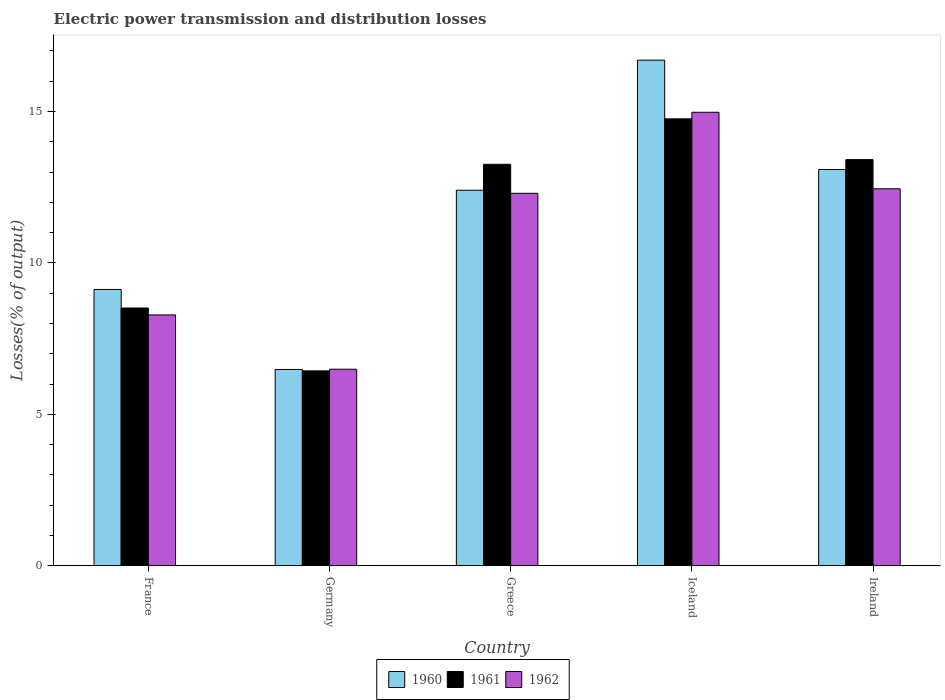How many different coloured bars are there?
Keep it short and to the point. 3. Are the number of bars per tick equal to the number of legend labels?
Keep it short and to the point. Yes. Are the number of bars on each tick of the X-axis equal?
Your answer should be compact. Yes. How many bars are there on the 1st tick from the left?
Give a very brief answer. 3. What is the label of the 5th group of bars from the left?
Keep it short and to the point. Ireland. What is the electric power transmission and distribution losses in 1960 in Ireland?
Offer a terse response. 13.09. Across all countries, what is the maximum electric power transmission and distribution losses in 1962?
Make the answer very short. 14.98. Across all countries, what is the minimum electric power transmission and distribution losses in 1961?
Give a very brief answer. 6.44. In which country was the electric power transmission and distribution losses in 1961 maximum?
Make the answer very short. Iceland. In which country was the electric power transmission and distribution losses in 1962 minimum?
Your response must be concise. Germany. What is the total electric power transmission and distribution losses in 1962 in the graph?
Provide a short and direct response. 54.5. What is the difference between the electric power transmission and distribution losses in 1961 in Germany and that in Iceland?
Provide a short and direct response. -8.32. What is the difference between the electric power transmission and distribution losses in 1960 in Ireland and the electric power transmission and distribution losses in 1961 in Germany?
Provide a short and direct response. 6.65. What is the average electric power transmission and distribution losses in 1962 per country?
Your answer should be very brief. 10.9. What is the difference between the electric power transmission and distribution losses of/in 1961 and electric power transmission and distribution losses of/in 1962 in Greece?
Your answer should be very brief. 0.96. What is the ratio of the electric power transmission and distribution losses in 1961 in Greece to that in Ireland?
Keep it short and to the point. 0.99. What is the difference between the highest and the second highest electric power transmission and distribution losses in 1962?
Ensure brevity in your answer.  0.15. What is the difference between the highest and the lowest electric power transmission and distribution losses in 1960?
Ensure brevity in your answer.  10.21. In how many countries, is the electric power transmission and distribution losses in 1961 greater than the average electric power transmission and distribution losses in 1961 taken over all countries?
Make the answer very short. 3. Is the sum of the electric power transmission and distribution losses in 1962 in Germany and Iceland greater than the maximum electric power transmission and distribution losses in 1961 across all countries?
Give a very brief answer. Yes. What does the 1st bar from the left in France represents?
Make the answer very short. 1960. How many countries are there in the graph?
Your answer should be compact. 5. What is the difference between two consecutive major ticks on the Y-axis?
Provide a succinct answer. 5. Does the graph contain any zero values?
Keep it short and to the point. No. Does the graph contain grids?
Your answer should be very brief. No. Where does the legend appear in the graph?
Your answer should be compact. Bottom center. How are the legend labels stacked?
Your answer should be compact. Horizontal. What is the title of the graph?
Your answer should be compact. Electric power transmission and distribution losses. What is the label or title of the X-axis?
Offer a terse response. Country. What is the label or title of the Y-axis?
Make the answer very short. Losses(% of output). What is the Losses(% of output) in 1960 in France?
Your answer should be compact. 9.12. What is the Losses(% of output) of 1961 in France?
Give a very brief answer. 8.51. What is the Losses(% of output) of 1962 in France?
Your answer should be very brief. 8.28. What is the Losses(% of output) in 1960 in Germany?
Provide a succinct answer. 6.48. What is the Losses(% of output) of 1961 in Germany?
Your answer should be very brief. 6.44. What is the Losses(% of output) of 1962 in Germany?
Provide a succinct answer. 6.49. What is the Losses(% of output) in 1960 in Greece?
Give a very brief answer. 12.4. What is the Losses(% of output) in 1961 in Greece?
Provide a short and direct response. 13.26. What is the Losses(% of output) in 1962 in Greece?
Keep it short and to the point. 12.3. What is the Losses(% of output) of 1960 in Iceland?
Keep it short and to the point. 16.7. What is the Losses(% of output) in 1961 in Iceland?
Ensure brevity in your answer.  14.76. What is the Losses(% of output) of 1962 in Iceland?
Ensure brevity in your answer.  14.98. What is the Losses(% of output) in 1960 in Ireland?
Give a very brief answer. 13.09. What is the Losses(% of output) of 1961 in Ireland?
Ensure brevity in your answer.  13.41. What is the Losses(% of output) in 1962 in Ireland?
Your response must be concise. 12.45. Across all countries, what is the maximum Losses(% of output) in 1960?
Make the answer very short. 16.7. Across all countries, what is the maximum Losses(% of output) of 1961?
Keep it short and to the point. 14.76. Across all countries, what is the maximum Losses(% of output) in 1962?
Offer a terse response. 14.98. Across all countries, what is the minimum Losses(% of output) of 1960?
Make the answer very short. 6.48. Across all countries, what is the minimum Losses(% of output) of 1961?
Offer a very short reply. 6.44. Across all countries, what is the minimum Losses(% of output) in 1962?
Your response must be concise. 6.49. What is the total Losses(% of output) of 1960 in the graph?
Keep it short and to the point. 57.79. What is the total Losses(% of output) of 1961 in the graph?
Provide a succinct answer. 56.38. What is the total Losses(% of output) of 1962 in the graph?
Ensure brevity in your answer.  54.5. What is the difference between the Losses(% of output) in 1960 in France and that in Germany?
Offer a very short reply. 2.64. What is the difference between the Losses(% of output) in 1961 in France and that in Germany?
Your answer should be very brief. 2.08. What is the difference between the Losses(% of output) of 1962 in France and that in Germany?
Your response must be concise. 1.79. What is the difference between the Losses(% of output) in 1960 in France and that in Greece?
Give a very brief answer. -3.28. What is the difference between the Losses(% of output) in 1961 in France and that in Greece?
Give a very brief answer. -4.75. What is the difference between the Losses(% of output) of 1962 in France and that in Greece?
Your answer should be compact. -4.02. What is the difference between the Losses(% of output) of 1960 in France and that in Iceland?
Your answer should be compact. -7.57. What is the difference between the Losses(% of output) in 1961 in France and that in Iceland?
Offer a terse response. -6.25. What is the difference between the Losses(% of output) of 1962 in France and that in Iceland?
Offer a very short reply. -6.69. What is the difference between the Losses(% of output) in 1960 in France and that in Ireland?
Your response must be concise. -3.96. What is the difference between the Losses(% of output) in 1961 in France and that in Ireland?
Ensure brevity in your answer.  -4.9. What is the difference between the Losses(% of output) in 1962 in France and that in Ireland?
Make the answer very short. -4.17. What is the difference between the Losses(% of output) of 1960 in Germany and that in Greece?
Ensure brevity in your answer.  -5.92. What is the difference between the Losses(% of output) in 1961 in Germany and that in Greece?
Provide a succinct answer. -6.82. What is the difference between the Losses(% of output) in 1962 in Germany and that in Greece?
Keep it short and to the point. -5.81. What is the difference between the Losses(% of output) of 1960 in Germany and that in Iceland?
Ensure brevity in your answer.  -10.21. What is the difference between the Losses(% of output) of 1961 in Germany and that in Iceland?
Make the answer very short. -8.32. What is the difference between the Losses(% of output) of 1962 in Germany and that in Iceland?
Keep it short and to the point. -8.48. What is the difference between the Losses(% of output) in 1960 in Germany and that in Ireland?
Your response must be concise. -6.6. What is the difference between the Losses(% of output) of 1961 in Germany and that in Ireland?
Ensure brevity in your answer.  -6.98. What is the difference between the Losses(% of output) of 1962 in Germany and that in Ireland?
Make the answer very short. -5.96. What is the difference between the Losses(% of output) of 1960 in Greece and that in Iceland?
Provide a succinct answer. -4.3. What is the difference between the Losses(% of output) of 1961 in Greece and that in Iceland?
Give a very brief answer. -1.5. What is the difference between the Losses(% of output) in 1962 in Greece and that in Iceland?
Make the answer very short. -2.68. What is the difference between the Losses(% of output) in 1960 in Greece and that in Ireland?
Offer a terse response. -0.68. What is the difference between the Losses(% of output) in 1961 in Greece and that in Ireland?
Provide a succinct answer. -0.15. What is the difference between the Losses(% of output) in 1962 in Greece and that in Ireland?
Provide a succinct answer. -0.15. What is the difference between the Losses(% of output) of 1960 in Iceland and that in Ireland?
Keep it short and to the point. 3.61. What is the difference between the Losses(% of output) of 1961 in Iceland and that in Ireland?
Keep it short and to the point. 1.35. What is the difference between the Losses(% of output) in 1962 in Iceland and that in Ireland?
Your answer should be compact. 2.53. What is the difference between the Losses(% of output) of 1960 in France and the Losses(% of output) of 1961 in Germany?
Ensure brevity in your answer.  2.69. What is the difference between the Losses(% of output) in 1960 in France and the Losses(% of output) in 1962 in Germany?
Make the answer very short. 2.63. What is the difference between the Losses(% of output) in 1961 in France and the Losses(% of output) in 1962 in Germany?
Ensure brevity in your answer.  2.02. What is the difference between the Losses(% of output) of 1960 in France and the Losses(% of output) of 1961 in Greece?
Provide a short and direct response. -4.13. What is the difference between the Losses(% of output) of 1960 in France and the Losses(% of output) of 1962 in Greece?
Your answer should be very brief. -3.18. What is the difference between the Losses(% of output) in 1961 in France and the Losses(% of output) in 1962 in Greece?
Provide a succinct answer. -3.79. What is the difference between the Losses(% of output) in 1960 in France and the Losses(% of output) in 1961 in Iceland?
Your answer should be very brief. -5.63. What is the difference between the Losses(% of output) of 1960 in France and the Losses(% of output) of 1962 in Iceland?
Your answer should be very brief. -5.85. What is the difference between the Losses(% of output) of 1961 in France and the Losses(% of output) of 1962 in Iceland?
Offer a very short reply. -6.46. What is the difference between the Losses(% of output) of 1960 in France and the Losses(% of output) of 1961 in Ireland?
Your answer should be compact. -4.29. What is the difference between the Losses(% of output) of 1960 in France and the Losses(% of output) of 1962 in Ireland?
Provide a short and direct response. -3.32. What is the difference between the Losses(% of output) in 1961 in France and the Losses(% of output) in 1962 in Ireland?
Give a very brief answer. -3.94. What is the difference between the Losses(% of output) of 1960 in Germany and the Losses(% of output) of 1961 in Greece?
Your answer should be compact. -6.78. What is the difference between the Losses(% of output) of 1960 in Germany and the Losses(% of output) of 1962 in Greece?
Give a very brief answer. -5.82. What is the difference between the Losses(% of output) in 1961 in Germany and the Losses(% of output) in 1962 in Greece?
Your answer should be compact. -5.86. What is the difference between the Losses(% of output) of 1960 in Germany and the Losses(% of output) of 1961 in Iceland?
Ensure brevity in your answer.  -8.28. What is the difference between the Losses(% of output) in 1960 in Germany and the Losses(% of output) in 1962 in Iceland?
Offer a terse response. -8.49. What is the difference between the Losses(% of output) in 1961 in Germany and the Losses(% of output) in 1962 in Iceland?
Your response must be concise. -8.54. What is the difference between the Losses(% of output) in 1960 in Germany and the Losses(% of output) in 1961 in Ireland?
Your answer should be very brief. -6.93. What is the difference between the Losses(% of output) of 1960 in Germany and the Losses(% of output) of 1962 in Ireland?
Keep it short and to the point. -5.97. What is the difference between the Losses(% of output) of 1961 in Germany and the Losses(% of output) of 1962 in Ireland?
Provide a short and direct response. -6.01. What is the difference between the Losses(% of output) of 1960 in Greece and the Losses(% of output) of 1961 in Iceland?
Keep it short and to the point. -2.36. What is the difference between the Losses(% of output) in 1960 in Greece and the Losses(% of output) in 1962 in Iceland?
Keep it short and to the point. -2.57. What is the difference between the Losses(% of output) in 1961 in Greece and the Losses(% of output) in 1962 in Iceland?
Offer a terse response. -1.72. What is the difference between the Losses(% of output) in 1960 in Greece and the Losses(% of output) in 1961 in Ireland?
Make the answer very short. -1.01. What is the difference between the Losses(% of output) in 1960 in Greece and the Losses(% of output) in 1962 in Ireland?
Your response must be concise. -0.05. What is the difference between the Losses(% of output) in 1961 in Greece and the Losses(% of output) in 1962 in Ireland?
Your answer should be compact. 0.81. What is the difference between the Losses(% of output) of 1960 in Iceland and the Losses(% of output) of 1961 in Ireland?
Your answer should be very brief. 3.28. What is the difference between the Losses(% of output) in 1960 in Iceland and the Losses(% of output) in 1962 in Ireland?
Make the answer very short. 4.25. What is the difference between the Losses(% of output) of 1961 in Iceland and the Losses(% of output) of 1962 in Ireland?
Offer a terse response. 2.31. What is the average Losses(% of output) of 1960 per country?
Keep it short and to the point. 11.56. What is the average Losses(% of output) in 1961 per country?
Ensure brevity in your answer.  11.28. What is the average Losses(% of output) of 1962 per country?
Your answer should be very brief. 10.9. What is the difference between the Losses(% of output) of 1960 and Losses(% of output) of 1961 in France?
Your answer should be compact. 0.61. What is the difference between the Losses(% of output) of 1960 and Losses(% of output) of 1962 in France?
Your response must be concise. 0.84. What is the difference between the Losses(% of output) of 1961 and Losses(% of output) of 1962 in France?
Make the answer very short. 0.23. What is the difference between the Losses(% of output) of 1960 and Losses(% of output) of 1961 in Germany?
Ensure brevity in your answer.  0.05. What is the difference between the Losses(% of output) in 1960 and Losses(% of output) in 1962 in Germany?
Your response must be concise. -0.01. What is the difference between the Losses(% of output) of 1961 and Losses(% of output) of 1962 in Germany?
Offer a terse response. -0.06. What is the difference between the Losses(% of output) of 1960 and Losses(% of output) of 1961 in Greece?
Your answer should be very brief. -0.86. What is the difference between the Losses(% of output) of 1960 and Losses(% of output) of 1962 in Greece?
Make the answer very short. 0.1. What is the difference between the Losses(% of output) of 1961 and Losses(% of output) of 1962 in Greece?
Offer a very short reply. 0.96. What is the difference between the Losses(% of output) in 1960 and Losses(% of output) in 1961 in Iceland?
Your response must be concise. 1.94. What is the difference between the Losses(% of output) in 1960 and Losses(% of output) in 1962 in Iceland?
Offer a terse response. 1.72. What is the difference between the Losses(% of output) of 1961 and Losses(% of output) of 1962 in Iceland?
Offer a terse response. -0.22. What is the difference between the Losses(% of output) of 1960 and Losses(% of output) of 1961 in Ireland?
Ensure brevity in your answer.  -0.33. What is the difference between the Losses(% of output) in 1960 and Losses(% of output) in 1962 in Ireland?
Your answer should be compact. 0.64. What is the difference between the Losses(% of output) in 1961 and Losses(% of output) in 1962 in Ireland?
Your answer should be compact. 0.96. What is the ratio of the Losses(% of output) of 1960 in France to that in Germany?
Your answer should be very brief. 1.41. What is the ratio of the Losses(% of output) of 1961 in France to that in Germany?
Give a very brief answer. 1.32. What is the ratio of the Losses(% of output) of 1962 in France to that in Germany?
Keep it short and to the point. 1.28. What is the ratio of the Losses(% of output) of 1960 in France to that in Greece?
Offer a very short reply. 0.74. What is the ratio of the Losses(% of output) of 1961 in France to that in Greece?
Ensure brevity in your answer.  0.64. What is the ratio of the Losses(% of output) in 1962 in France to that in Greece?
Offer a very short reply. 0.67. What is the ratio of the Losses(% of output) of 1960 in France to that in Iceland?
Provide a short and direct response. 0.55. What is the ratio of the Losses(% of output) of 1961 in France to that in Iceland?
Offer a very short reply. 0.58. What is the ratio of the Losses(% of output) in 1962 in France to that in Iceland?
Provide a succinct answer. 0.55. What is the ratio of the Losses(% of output) of 1960 in France to that in Ireland?
Give a very brief answer. 0.7. What is the ratio of the Losses(% of output) in 1961 in France to that in Ireland?
Your response must be concise. 0.63. What is the ratio of the Losses(% of output) in 1962 in France to that in Ireland?
Your answer should be very brief. 0.67. What is the ratio of the Losses(% of output) of 1960 in Germany to that in Greece?
Keep it short and to the point. 0.52. What is the ratio of the Losses(% of output) of 1961 in Germany to that in Greece?
Your answer should be very brief. 0.49. What is the ratio of the Losses(% of output) in 1962 in Germany to that in Greece?
Offer a very short reply. 0.53. What is the ratio of the Losses(% of output) of 1960 in Germany to that in Iceland?
Your answer should be compact. 0.39. What is the ratio of the Losses(% of output) in 1961 in Germany to that in Iceland?
Offer a terse response. 0.44. What is the ratio of the Losses(% of output) of 1962 in Germany to that in Iceland?
Your answer should be compact. 0.43. What is the ratio of the Losses(% of output) in 1960 in Germany to that in Ireland?
Offer a terse response. 0.5. What is the ratio of the Losses(% of output) of 1961 in Germany to that in Ireland?
Your response must be concise. 0.48. What is the ratio of the Losses(% of output) in 1962 in Germany to that in Ireland?
Make the answer very short. 0.52. What is the ratio of the Losses(% of output) of 1960 in Greece to that in Iceland?
Your response must be concise. 0.74. What is the ratio of the Losses(% of output) in 1961 in Greece to that in Iceland?
Make the answer very short. 0.9. What is the ratio of the Losses(% of output) in 1962 in Greece to that in Iceland?
Your answer should be very brief. 0.82. What is the ratio of the Losses(% of output) of 1960 in Greece to that in Ireland?
Offer a very short reply. 0.95. What is the ratio of the Losses(% of output) of 1961 in Greece to that in Ireland?
Ensure brevity in your answer.  0.99. What is the ratio of the Losses(% of output) in 1960 in Iceland to that in Ireland?
Your answer should be very brief. 1.28. What is the ratio of the Losses(% of output) of 1961 in Iceland to that in Ireland?
Ensure brevity in your answer.  1.1. What is the ratio of the Losses(% of output) of 1962 in Iceland to that in Ireland?
Provide a short and direct response. 1.2. What is the difference between the highest and the second highest Losses(% of output) in 1960?
Provide a succinct answer. 3.61. What is the difference between the highest and the second highest Losses(% of output) in 1961?
Keep it short and to the point. 1.35. What is the difference between the highest and the second highest Losses(% of output) in 1962?
Ensure brevity in your answer.  2.53. What is the difference between the highest and the lowest Losses(% of output) in 1960?
Your answer should be compact. 10.21. What is the difference between the highest and the lowest Losses(% of output) of 1961?
Offer a terse response. 8.32. What is the difference between the highest and the lowest Losses(% of output) of 1962?
Your answer should be very brief. 8.48. 